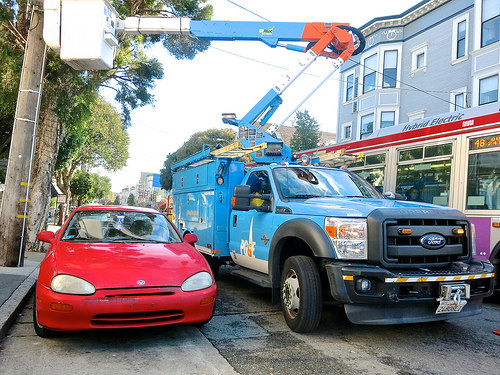<image>
Can you confirm if the bus is to the left of the car? No. The bus is not to the left of the car. From this viewpoint, they have a different horizontal relationship. 